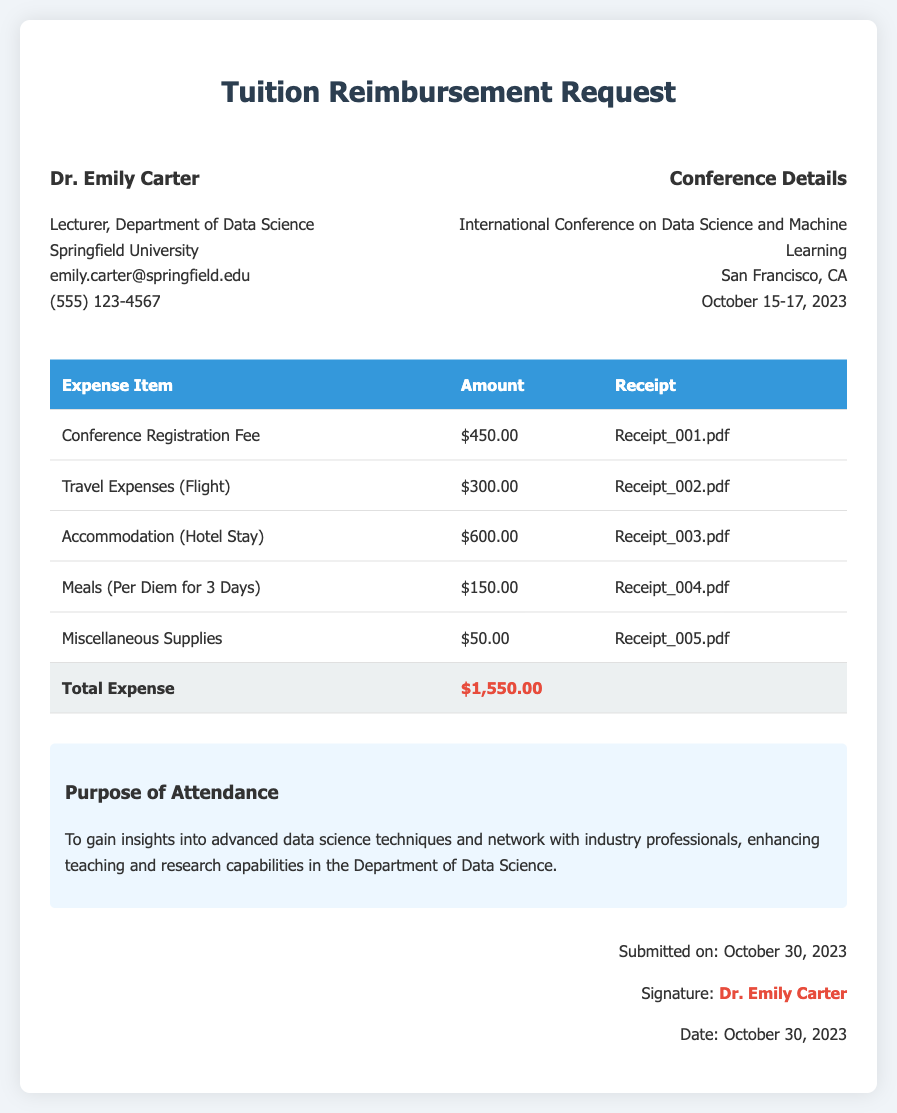What is the name of the requester? The requester's name is stated at the top of the document as Dr. Emily Carter.
Answer: Dr. Emily Carter What is the total amount of the expenses? The total expenses are summed in the table, showing $1,550.00.
Answer: $1,550.00 When did the conference take place? The dates of the conference are mentioned in the conference details section as October 15-17, 2023.
Answer: October 15-17, 2023 What was the purpose of attendance? The purpose is provided in the document and states insights into advanced data science techniques and networking for enhancing teaching and research capabilities.
Answer: To gain insights into advanced data science techniques and network with industry professionals How much was spent on accommodation? The accommodation expense is listed in the breakdown, showing $600.00 spent on hotel stay.
Answer: $600.00 Are there any miscellaneous supplies listed? The table includes an item labeled 'Miscellaneous Supplies' with an associated expense.
Answer: Yes What is the email address of the requester? The requester's email is included in the contact information section as emily.carter@springfield.edu.
Answer: emily.carter@springfield.edu How many days of meals per diem were accounted for? The meals expense mentions a per diem for 3 days in the breakdown of expenses.
Answer: 3 days Who submitted the request? The signature section indicates that Dr. Emily Carter submitted the request.
Answer: Dr. Emily Carter 